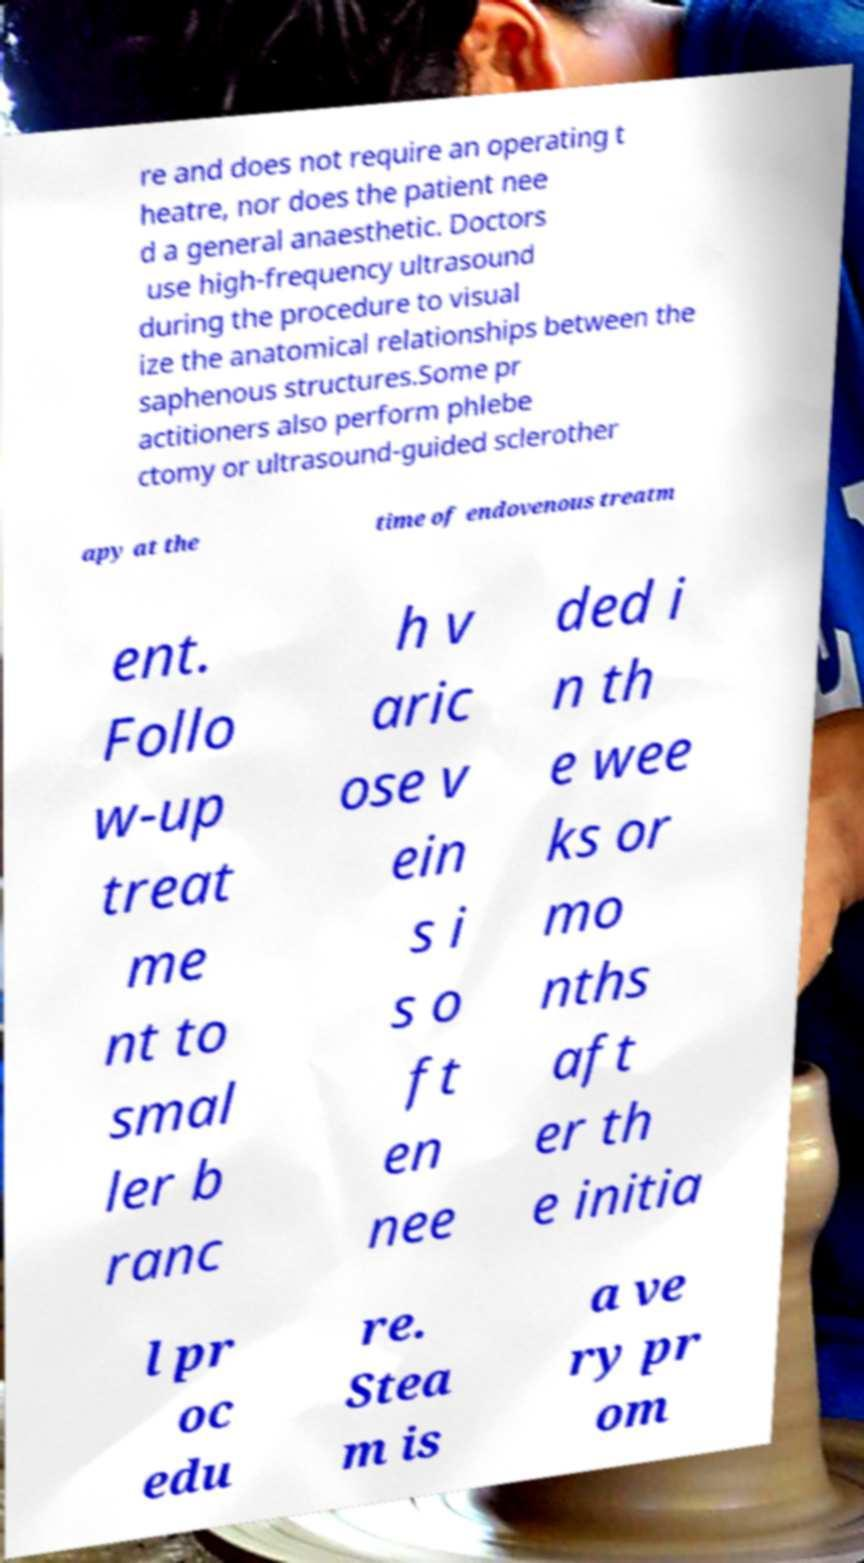For documentation purposes, I need the text within this image transcribed. Could you provide that? re and does not require an operating t heatre, nor does the patient nee d a general anaesthetic. Doctors use high-frequency ultrasound during the procedure to visual ize the anatomical relationships between the saphenous structures.Some pr actitioners also perform phlebe ctomy or ultrasound-guided sclerother apy at the time of endovenous treatm ent. Follo w-up treat me nt to smal ler b ranc h v aric ose v ein s i s o ft en nee ded i n th e wee ks or mo nths aft er th e initia l pr oc edu re. Stea m is a ve ry pr om 